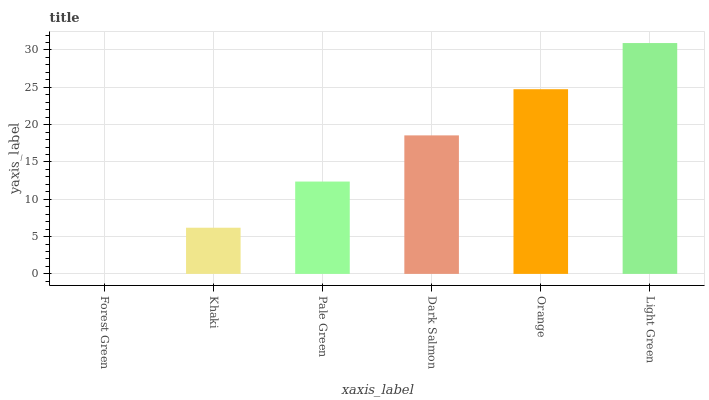Is Forest Green the minimum?
Answer yes or no. Yes. Is Light Green the maximum?
Answer yes or no. Yes. Is Khaki the minimum?
Answer yes or no. No. Is Khaki the maximum?
Answer yes or no. No. Is Khaki greater than Forest Green?
Answer yes or no. Yes. Is Forest Green less than Khaki?
Answer yes or no. Yes. Is Forest Green greater than Khaki?
Answer yes or no. No. Is Khaki less than Forest Green?
Answer yes or no. No. Is Dark Salmon the high median?
Answer yes or no. Yes. Is Pale Green the low median?
Answer yes or no. Yes. Is Orange the high median?
Answer yes or no. No. Is Forest Green the low median?
Answer yes or no. No. 